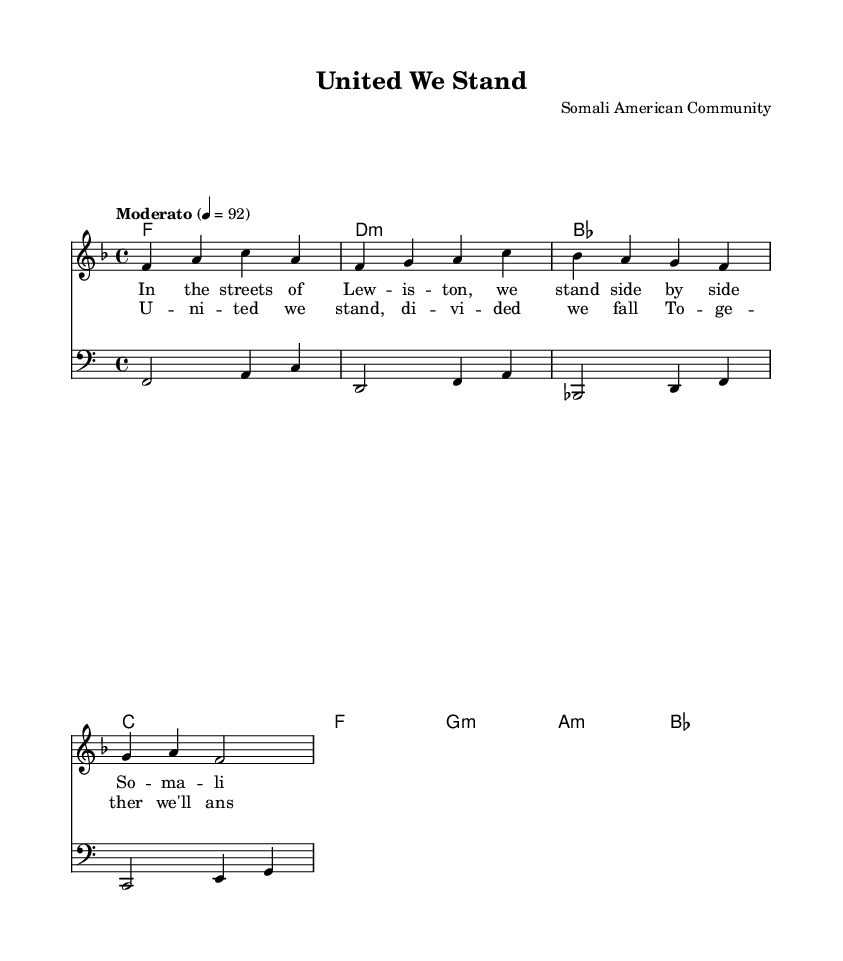What is the key signature of this music? The key signature is F major, indicated by one flat (B). It can be found at the beginning of the staff before the first measure.
Answer: F major What is the time signature of this music? The time signature is 4/4, which is shown at the beginning of the piece. This means there are four beats per measure and the quarter note receives one beat.
Answer: 4/4 What is the tempo marking of this music? The tempo marking indicates "Moderato," which suggests a moderate speed. This is placed above the staff at the beginning of the score, along with the metronome marking of 92 beats per minute.
Answer: Moderato How many measures are in the melody section? The melody section contains four measures, as each measure is separated by vertical bar lines on the staff. Counting the spaces between these bar lines shows there are four distinct measures.
Answer: Four What chord follows the F chord in the harmony? The chord that follows the F chord in the harmony is D minor, which can be found as the second chord in the harmonic progression indicated below the staff.
Answer: D minor What is the main theme of the lyrics represented in the chorus? The main theme of the chorus emphasizes unity and community, as it expresses the idea "United we stand, divided we fall." This idea is reflected in the repeated need for togetherness and community strength in the lyrics.
Answer: Unity and community 